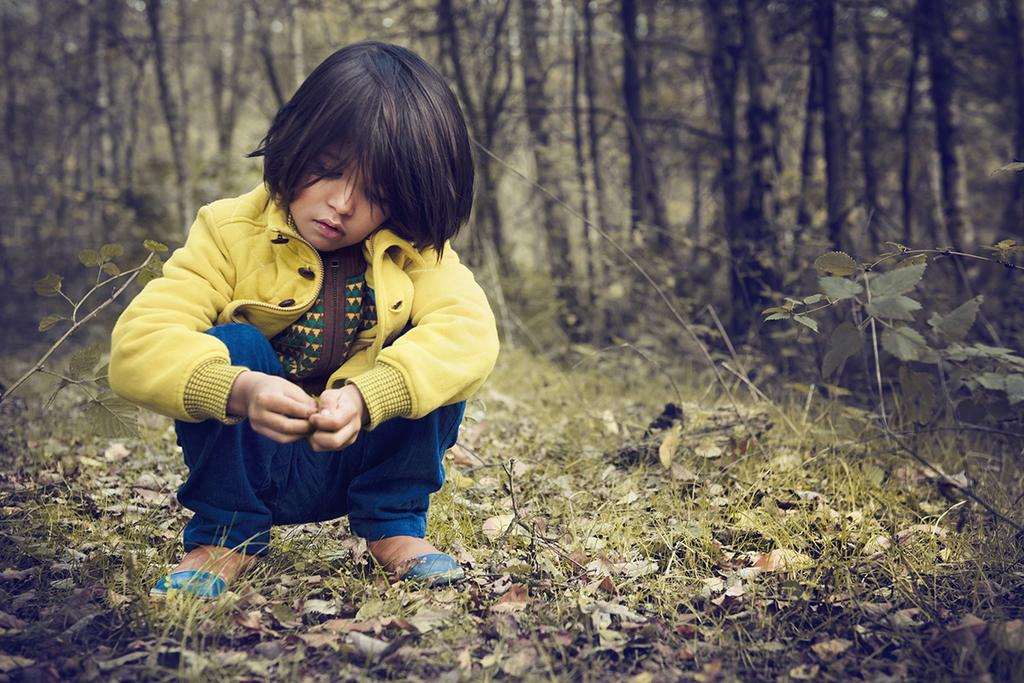What is the child doing in the image? The child is sitting in the image. What type of surface is the child sitting on? The ground has grass in the image. What else can be seen on the ground? There are leaves visible on the ground. What type of vegetation is present in the image? There are plants in the image. What can be seen in the background of the image? There are trees in the background of the image. What type of comb is the child using in the image? There is no comb present in the image. How does the child's cough sound in the image? There is no coughing sound in the image. 